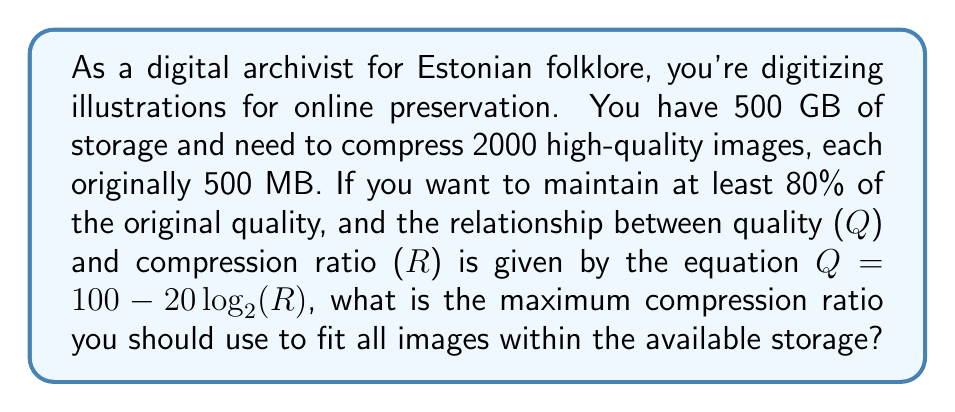Can you answer this question? Let's approach this step-by-step:

1) First, calculate the total original size of the images:
   $2000 \times 500 \text{ MB} = 1,000,000 \text{ MB} = 1000 \text{ GB}$

2) To fit in 500 GB, we need a compression ratio of at least:
   $R = \frac{1000 \text{ GB}}{500 \text{ GB}} = 2$

3) Now, we need to check if this ratio maintains at least 80% quality.
   Using the given equation: $Q = 100 - 20\log_{2}(R)$

4) Substituting $R = 2$:
   $Q = 100 - 20\log_{2}(2) = 100 - 20 = 80$

5) This exactly meets our quality requirement. However, we need to find the maximum ratio that still maintains at least 80% quality.

6) Let's rearrange the equation to solve for R when Q = 80:
   $80 = 100 - 20\log_{2}(R)$
   $20 = 20\log_{2}(R)$
   $1 = \log_{2}(R)$
   $2^1 = R$
   $R = 2$

Therefore, the maximum compression ratio we can use while maintaining at least 80% quality is 2.
Answer: 2 